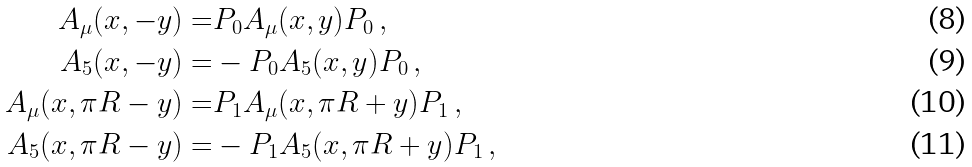Convert formula to latex. <formula><loc_0><loc_0><loc_500><loc_500>A _ { \mu } ( x , - y ) = & P _ { 0 } A _ { \mu } ( x , y ) P _ { 0 } \, , \\ A _ { 5 } ( x , - y ) = & - P _ { 0 } A _ { 5 } ( x , y ) P _ { 0 } \, , \\ A _ { \mu } ( x , \pi R - y ) = & P _ { 1 } A _ { \mu } ( x , \pi R + y ) P _ { 1 } \, , \\ A _ { 5 } ( x , \pi R - y ) = & - P _ { 1 } A _ { 5 } ( x , \pi R + y ) P _ { 1 } \, ,</formula> 